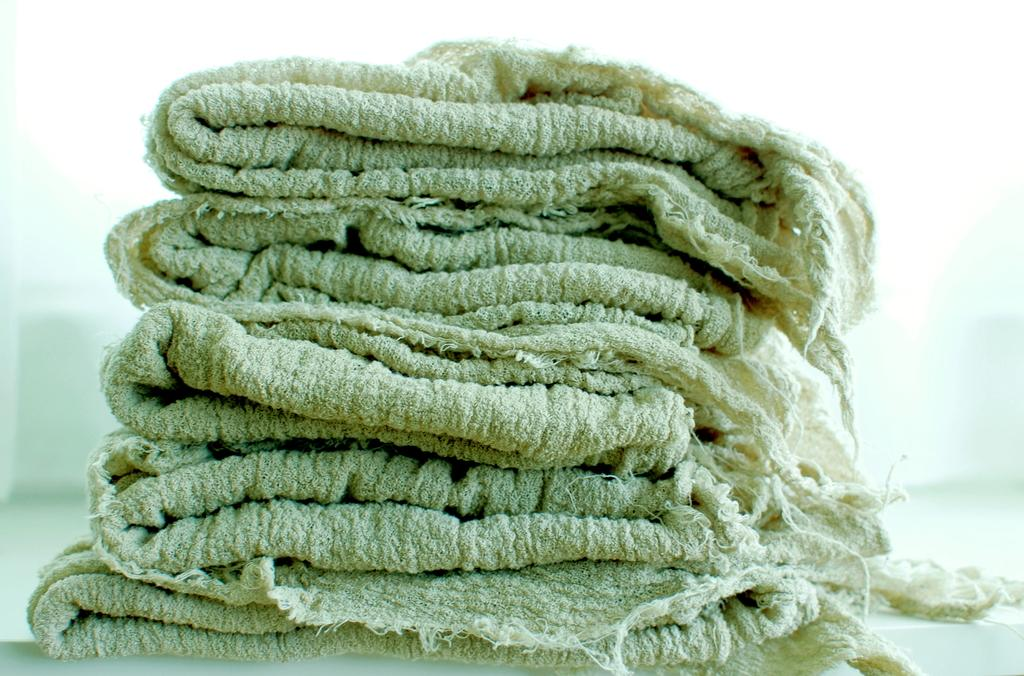What is located in the middle of the image? There are clothes in the middle of the image. What surface can be seen at the bottom of the image? There is a floor visible at the bottom of the image. What type of insurance policy is being discussed in the image? There is no mention of insurance or any discussion in the image; it only features clothes and a floor. 